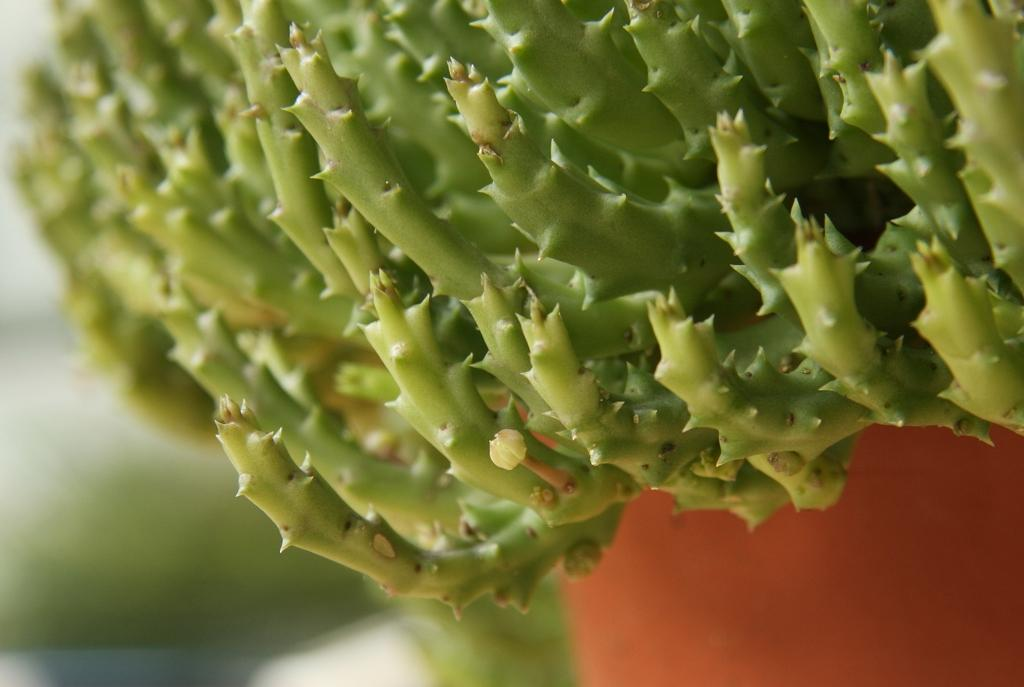What is the main subject of the image? The main subject of the image is a plant. How is the plant contained in the image? The plant is in a pot. Can you describe the background of the image? The background of the image is blurred. How many tickets are visible in the image? There are no tickets present in the image. Is there a ring on the plant in the image? There is no ring visible on the plant in the image. 